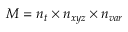<formula> <loc_0><loc_0><loc_500><loc_500>M = n _ { t } \times { n _ { x y z } } \times { n _ { v a r } }</formula> 